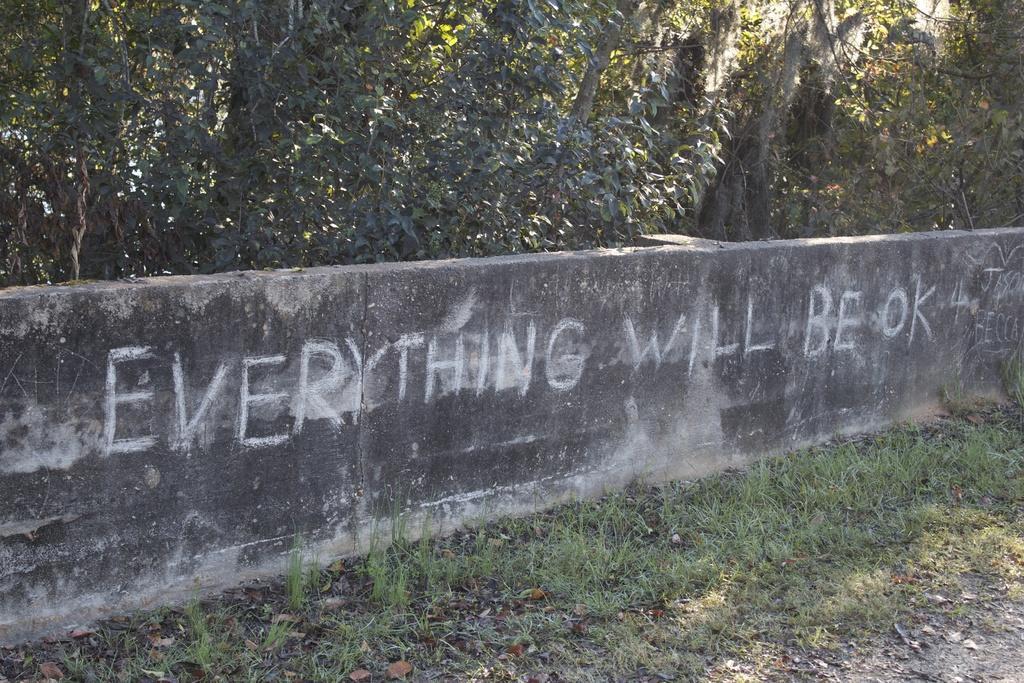Describe this image in one or two sentences. In this picture we can see the wall and trees. On the wall we can read that everything will be ok. At bottom we can see the grass and leaves. In the top right there is a sky. In the background we can see the building. 